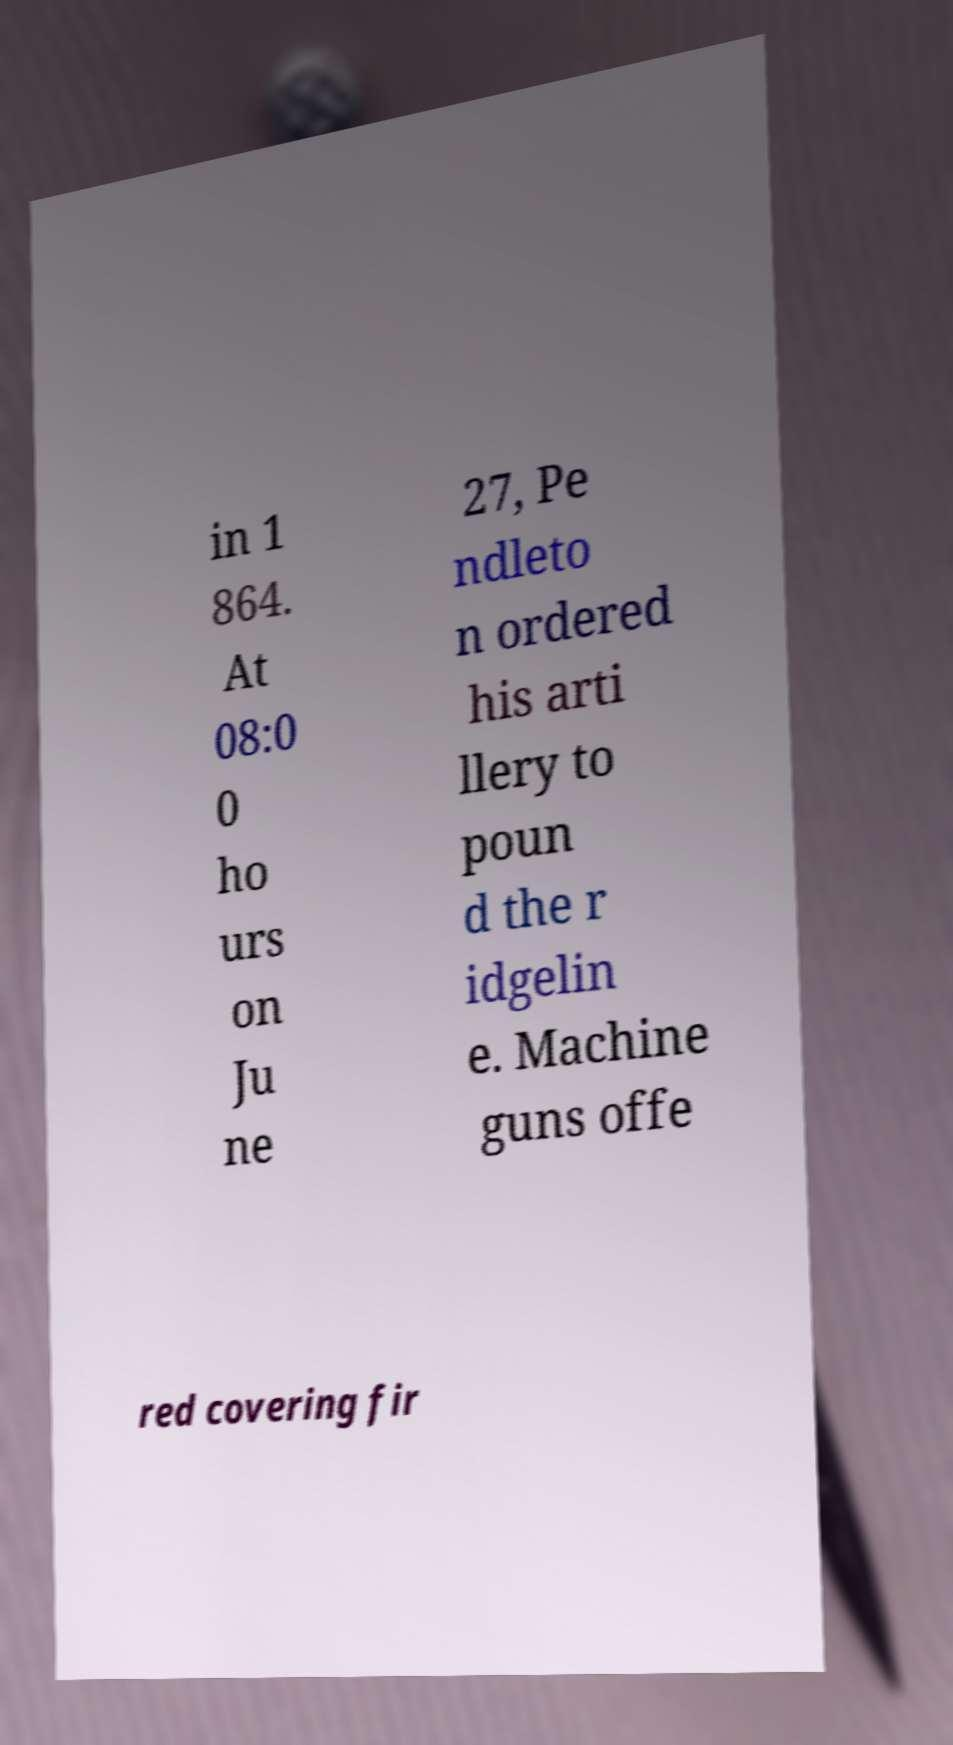Could you assist in decoding the text presented in this image and type it out clearly? in 1 864. At 08:0 0 ho urs on Ju ne 27, Pe ndleto n ordered his arti llery to poun d the r idgelin e. Machine guns offe red covering fir 